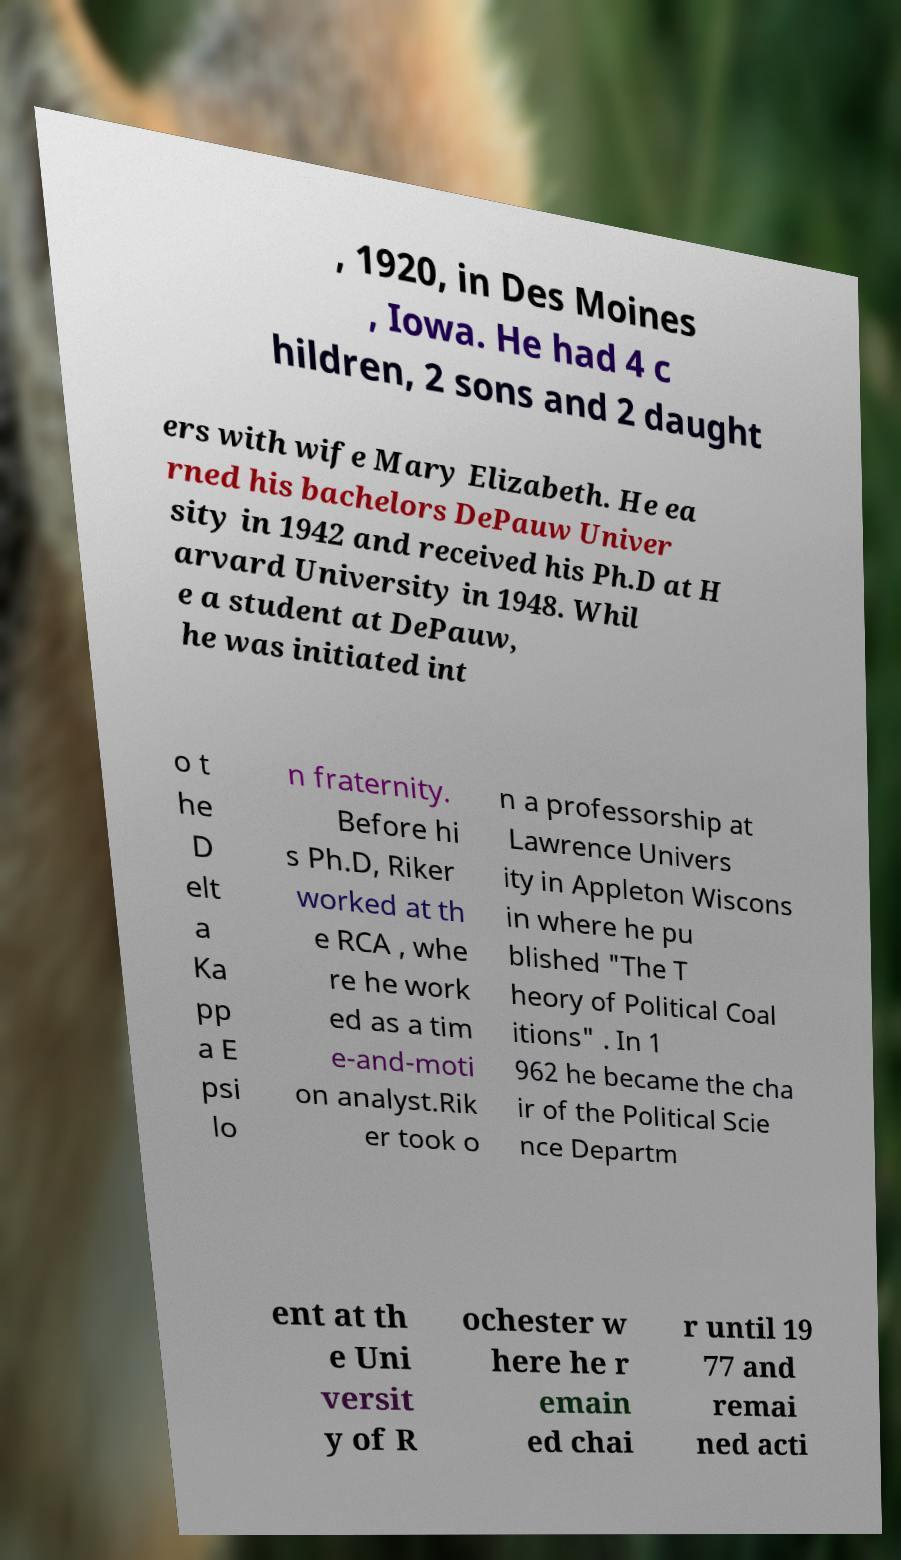I need the written content from this picture converted into text. Can you do that? , 1920, in Des Moines , Iowa. He had 4 c hildren, 2 sons and 2 daught ers with wife Mary Elizabeth. He ea rned his bachelors DePauw Univer sity in 1942 and received his Ph.D at H arvard University in 1948. Whil e a student at DePauw, he was initiated int o t he D elt a Ka pp a E psi lo n fraternity. Before hi s Ph.D, Riker worked at th e RCA , whe re he work ed as a tim e-and-moti on analyst.Rik er took o n a professorship at Lawrence Univers ity in Appleton Wiscons in where he pu blished "The T heory of Political Coal itions" . In 1 962 he became the cha ir of the Political Scie nce Departm ent at th e Uni versit y of R ochester w here he r emain ed chai r until 19 77 and remai ned acti 